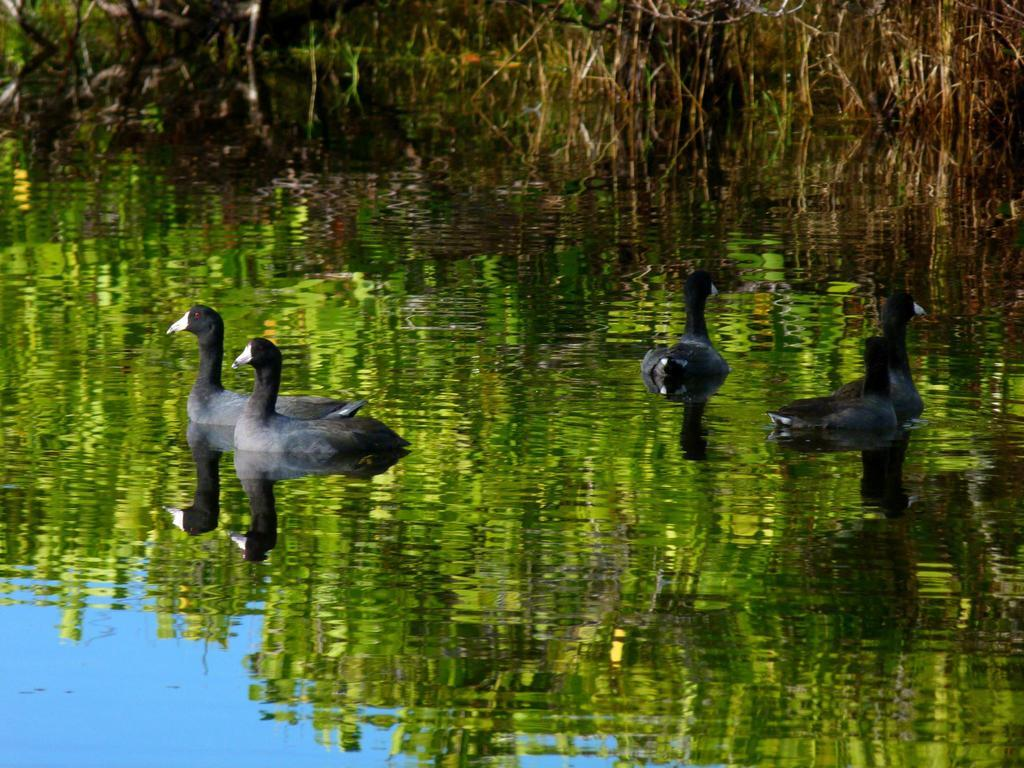What type of animals are in the image? There are four black and grey ducks in the image. What are the ducks doing in the image? The ducks are swimming in a small water pound. What can be seen in the background of the image? There is dry grass visible in the image. How many lizards are wearing stockings in the image? There are no lizards or stockings present in the image. 